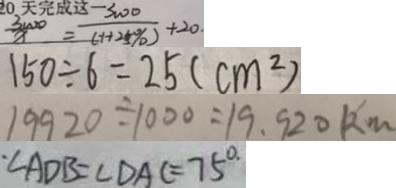<formula> <loc_0><loc_0><loc_500><loc_500>\frac { 3 0 0 0 } { x } = \frac { 3 0 0 0 } { 1 + 2 5 \% } + 2 0 . 
 1 5 0 \div 6 = 2 5 ( c m ^ { 2 } ) 
 1 9 9 2 0 \div 1 0 0 0 = 1 9 . 9 2 0 k m 
 \cdot \angle A D B = \angle D A C = 7 5 ^ { \circ }</formula> 